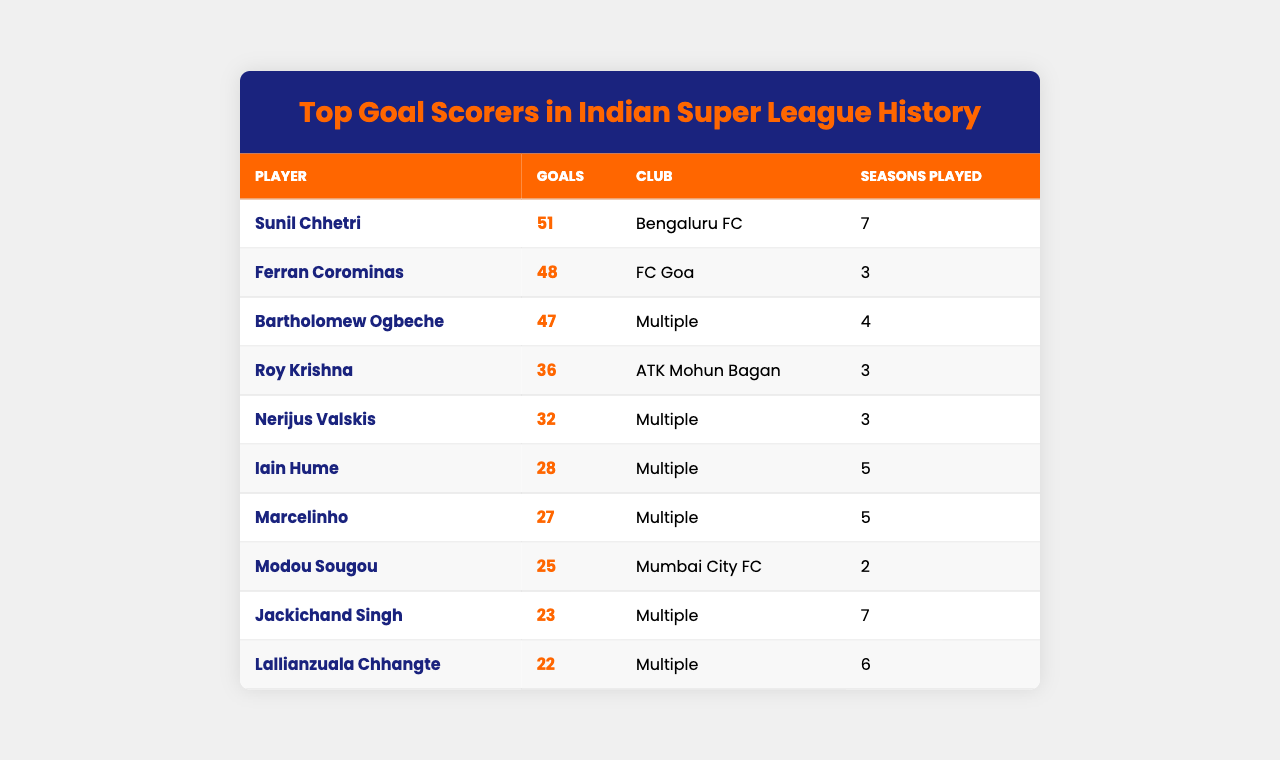What is the total number of goals scored by Sunil Chhetri? According to the table, Sunil Chhetri has scored a total of 51 goals.
Answer: 51 Who played for FC Goa and scored 48 goals? The table indicates that Ferran Corominas played for FC Goa and scored 48 goals.
Answer: Ferran Corominas How many seasons did Bartholomew Ogbeche play? The table shows that Bartholomew Ogbeche played for 4 seasons.
Answer: 4 Which player has the most goals? By looking at the table, Sunil Chhetri has the highest number of goals with 51.
Answer: Sunil Chhetri Is Roy Krishna among the top goal scorers in ISL history? Yes, the table lists Roy Krishna, who scored 36 goals, placing him among the top goal scorers.
Answer: Yes What is the difference in goals between Sunil Chhetri and Ferran Corominas? Sunil Chhetri scored 51 goals and Ferran Corominas scored 48 goals, so the difference is 51 - 48 = 3 goals.
Answer: 3 Who is the only player in the list who has played for Mumbai City FC? Looking at the table, Modou Sougou is the only player listed as playing for Mumbai City FC.
Answer: Modou Sougou What is the average number of goals scored by the top three players? The top three players are Sunil Chhetri (51), Ferran Corominas (48), and Bartholomew Ogbeche (47). The total goals scored by them is 51 + 48 + 47 = 146. The average is 146/3 = 48.67.
Answer: 48.67 How many players have scored more than 30 goals in ISL history? By checking the table, there are five players with more than 30 goals: Sunil Chhetri (51), Ferran Corominas (48), Bartholomew Ogbeche (47), Roy Krishna (36), and Nerijus Valskis (32).
Answer: 5 Which player's total goals is an even number? From the table, Bartholomew Ogbeche (47) and Modou Sougou (25) have odd goals, while others like Nerijus Valskis (32) have even goals. Therefore, the answer is Nerijus Valskis.
Answer: Nerijus Valskis What percentage of his total goals did Iain Hume score compared to Sunil Chhetri? Iain Hume scored 28 goals while Sunil Chhetri scored 51. The percentage is (28/51)*100 ≈ 54.9%.
Answer: 54.9% 